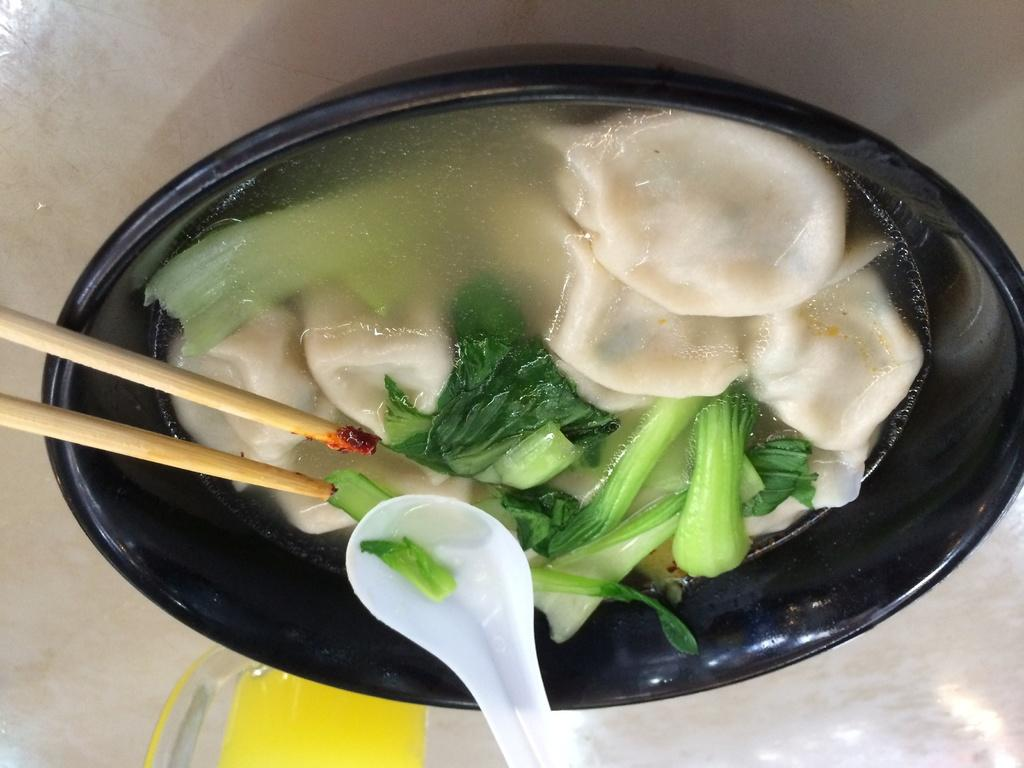What is the color of the bowl in the image? The bowl is black in color. What type of food is in the bowl? The food contains green leafy vegetables. How can the food be eaten? The bowl has a spoon on it, and there are also two chopsticks in the image. Can you see the person's toes in the image? There is no person or toes visible in the image; it only shows a black bowl with food and utensils. 